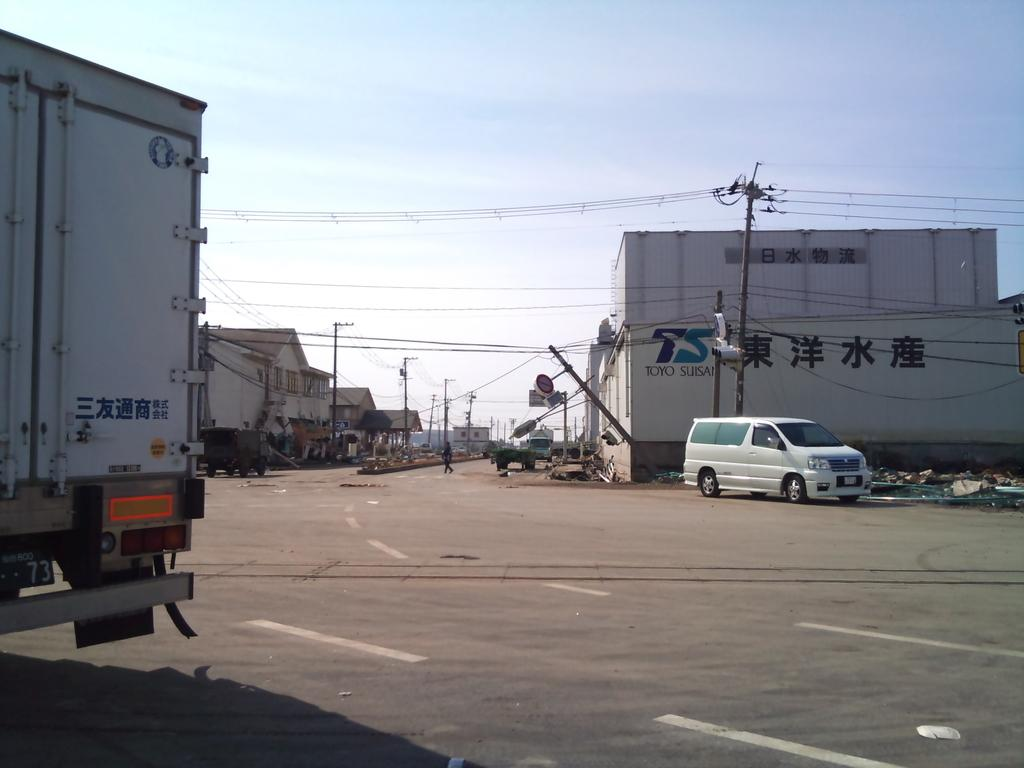What types of objects are present on the road in the image? There are vehicles in the image. What is the person in the image doing? A person is walking on the road in the image. What can be seen on the buildings in the image? There are buildings with windows in the image. What are the poles used for in the image? Poles are present in the image, but their purpose is not specified. What are the wires connected to in the image? Wires are visible in the image, but their connection points are not specified. What is visible in the background of the image? The sky is visible in the background of the image. What committee is responsible for the existence of the wires in the image? There is no information about a committee responsible for the wires in the image. Can you tell me how many noses are visible in the image? There are no noses visible in the image. 